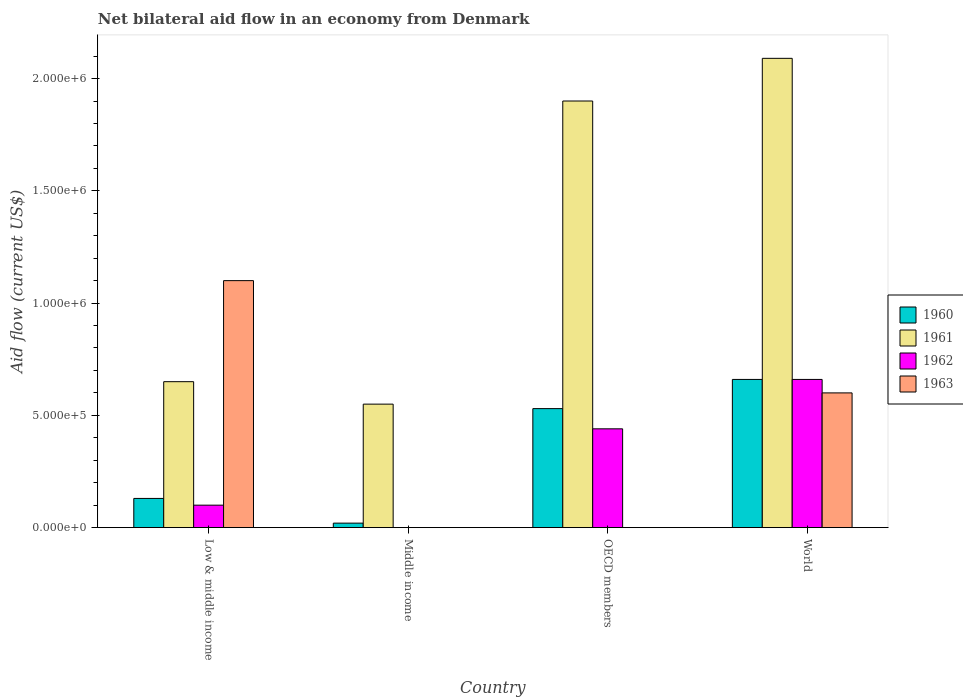How many groups of bars are there?
Keep it short and to the point. 4. Are the number of bars per tick equal to the number of legend labels?
Provide a succinct answer. No. Are the number of bars on each tick of the X-axis equal?
Give a very brief answer. No. How many bars are there on the 1st tick from the right?
Give a very brief answer. 4. What is the net bilateral aid flow in 1961 in World?
Ensure brevity in your answer.  2.09e+06. Across all countries, what is the maximum net bilateral aid flow in 1960?
Your response must be concise. 6.60e+05. Across all countries, what is the minimum net bilateral aid flow in 1962?
Offer a terse response. 0. In which country was the net bilateral aid flow in 1961 maximum?
Keep it short and to the point. World. What is the total net bilateral aid flow in 1961 in the graph?
Your response must be concise. 5.19e+06. What is the difference between the net bilateral aid flow in 1961 in World and the net bilateral aid flow in 1963 in Middle income?
Offer a very short reply. 2.09e+06. What is the average net bilateral aid flow in 1960 per country?
Your answer should be very brief. 3.35e+05. What is the difference between the net bilateral aid flow of/in 1960 and net bilateral aid flow of/in 1963 in World?
Offer a very short reply. 6.00e+04. In how many countries, is the net bilateral aid flow in 1962 greater than 500000 US$?
Keep it short and to the point. 1. What is the ratio of the net bilateral aid flow in 1963 in Low & middle income to that in World?
Your answer should be very brief. 1.83. What is the difference between the highest and the lowest net bilateral aid flow in 1960?
Keep it short and to the point. 6.40e+05. Is the sum of the net bilateral aid flow in 1961 in Middle income and OECD members greater than the maximum net bilateral aid flow in 1963 across all countries?
Your answer should be compact. Yes. Is it the case that in every country, the sum of the net bilateral aid flow in 1963 and net bilateral aid flow in 1960 is greater than the net bilateral aid flow in 1962?
Offer a very short reply. Yes. How many bars are there?
Your response must be concise. 13. Are all the bars in the graph horizontal?
Your answer should be very brief. No. How many countries are there in the graph?
Offer a very short reply. 4. Does the graph contain grids?
Make the answer very short. No. Where does the legend appear in the graph?
Provide a short and direct response. Center right. What is the title of the graph?
Offer a terse response. Net bilateral aid flow in an economy from Denmark. What is the label or title of the X-axis?
Give a very brief answer. Country. What is the label or title of the Y-axis?
Offer a terse response. Aid flow (current US$). What is the Aid flow (current US$) of 1960 in Low & middle income?
Offer a very short reply. 1.30e+05. What is the Aid flow (current US$) in 1961 in Low & middle income?
Offer a very short reply. 6.50e+05. What is the Aid flow (current US$) of 1963 in Low & middle income?
Offer a very short reply. 1.10e+06. What is the Aid flow (current US$) of 1960 in Middle income?
Offer a terse response. 2.00e+04. What is the Aid flow (current US$) of 1961 in Middle income?
Provide a succinct answer. 5.50e+05. What is the Aid flow (current US$) of 1962 in Middle income?
Ensure brevity in your answer.  0. What is the Aid flow (current US$) in 1963 in Middle income?
Give a very brief answer. 0. What is the Aid flow (current US$) in 1960 in OECD members?
Give a very brief answer. 5.30e+05. What is the Aid flow (current US$) of 1961 in OECD members?
Your answer should be very brief. 1.90e+06. What is the Aid flow (current US$) in 1962 in OECD members?
Offer a terse response. 4.40e+05. What is the Aid flow (current US$) in 1960 in World?
Your response must be concise. 6.60e+05. What is the Aid flow (current US$) of 1961 in World?
Your answer should be compact. 2.09e+06. Across all countries, what is the maximum Aid flow (current US$) in 1960?
Provide a short and direct response. 6.60e+05. Across all countries, what is the maximum Aid flow (current US$) of 1961?
Provide a short and direct response. 2.09e+06. Across all countries, what is the maximum Aid flow (current US$) in 1962?
Offer a very short reply. 6.60e+05. Across all countries, what is the maximum Aid flow (current US$) of 1963?
Keep it short and to the point. 1.10e+06. Across all countries, what is the minimum Aid flow (current US$) of 1960?
Ensure brevity in your answer.  2.00e+04. What is the total Aid flow (current US$) of 1960 in the graph?
Your response must be concise. 1.34e+06. What is the total Aid flow (current US$) of 1961 in the graph?
Make the answer very short. 5.19e+06. What is the total Aid flow (current US$) in 1962 in the graph?
Give a very brief answer. 1.20e+06. What is the total Aid flow (current US$) of 1963 in the graph?
Give a very brief answer. 1.70e+06. What is the difference between the Aid flow (current US$) in 1960 in Low & middle income and that in Middle income?
Your answer should be very brief. 1.10e+05. What is the difference between the Aid flow (current US$) of 1960 in Low & middle income and that in OECD members?
Provide a short and direct response. -4.00e+05. What is the difference between the Aid flow (current US$) in 1961 in Low & middle income and that in OECD members?
Give a very brief answer. -1.25e+06. What is the difference between the Aid flow (current US$) in 1960 in Low & middle income and that in World?
Your answer should be compact. -5.30e+05. What is the difference between the Aid flow (current US$) of 1961 in Low & middle income and that in World?
Your answer should be compact. -1.44e+06. What is the difference between the Aid flow (current US$) of 1962 in Low & middle income and that in World?
Your answer should be very brief. -5.60e+05. What is the difference between the Aid flow (current US$) of 1963 in Low & middle income and that in World?
Ensure brevity in your answer.  5.00e+05. What is the difference between the Aid flow (current US$) in 1960 in Middle income and that in OECD members?
Your answer should be compact. -5.10e+05. What is the difference between the Aid flow (current US$) of 1961 in Middle income and that in OECD members?
Your answer should be very brief. -1.35e+06. What is the difference between the Aid flow (current US$) in 1960 in Middle income and that in World?
Your response must be concise. -6.40e+05. What is the difference between the Aid flow (current US$) in 1961 in Middle income and that in World?
Keep it short and to the point. -1.54e+06. What is the difference between the Aid flow (current US$) of 1961 in OECD members and that in World?
Your answer should be very brief. -1.90e+05. What is the difference between the Aid flow (current US$) in 1962 in OECD members and that in World?
Provide a short and direct response. -2.20e+05. What is the difference between the Aid flow (current US$) in 1960 in Low & middle income and the Aid flow (current US$) in 1961 in Middle income?
Offer a very short reply. -4.20e+05. What is the difference between the Aid flow (current US$) of 1960 in Low & middle income and the Aid flow (current US$) of 1961 in OECD members?
Provide a short and direct response. -1.77e+06. What is the difference between the Aid flow (current US$) of 1960 in Low & middle income and the Aid flow (current US$) of 1962 in OECD members?
Your response must be concise. -3.10e+05. What is the difference between the Aid flow (current US$) of 1960 in Low & middle income and the Aid flow (current US$) of 1961 in World?
Make the answer very short. -1.96e+06. What is the difference between the Aid flow (current US$) in 1960 in Low & middle income and the Aid flow (current US$) in 1962 in World?
Your answer should be very brief. -5.30e+05. What is the difference between the Aid flow (current US$) in 1960 in Low & middle income and the Aid flow (current US$) in 1963 in World?
Keep it short and to the point. -4.70e+05. What is the difference between the Aid flow (current US$) in 1962 in Low & middle income and the Aid flow (current US$) in 1963 in World?
Offer a very short reply. -5.00e+05. What is the difference between the Aid flow (current US$) in 1960 in Middle income and the Aid flow (current US$) in 1961 in OECD members?
Your answer should be very brief. -1.88e+06. What is the difference between the Aid flow (current US$) in 1960 in Middle income and the Aid flow (current US$) in 1962 in OECD members?
Offer a terse response. -4.20e+05. What is the difference between the Aid flow (current US$) in 1961 in Middle income and the Aid flow (current US$) in 1962 in OECD members?
Offer a very short reply. 1.10e+05. What is the difference between the Aid flow (current US$) of 1960 in Middle income and the Aid flow (current US$) of 1961 in World?
Provide a succinct answer. -2.07e+06. What is the difference between the Aid flow (current US$) of 1960 in Middle income and the Aid flow (current US$) of 1962 in World?
Provide a succinct answer. -6.40e+05. What is the difference between the Aid flow (current US$) in 1960 in Middle income and the Aid flow (current US$) in 1963 in World?
Your response must be concise. -5.80e+05. What is the difference between the Aid flow (current US$) of 1961 in Middle income and the Aid flow (current US$) of 1962 in World?
Your answer should be very brief. -1.10e+05. What is the difference between the Aid flow (current US$) in 1960 in OECD members and the Aid flow (current US$) in 1961 in World?
Provide a short and direct response. -1.56e+06. What is the difference between the Aid flow (current US$) of 1961 in OECD members and the Aid flow (current US$) of 1962 in World?
Your response must be concise. 1.24e+06. What is the difference between the Aid flow (current US$) in 1961 in OECD members and the Aid flow (current US$) in 1963 in World?
Provide a succinct answer. 1.30e+06. What is the difference between the Aid flow (current US$) of 1962 in OECD members and the Aid flow (current US$) of 1963 in World?
Provide a succinct answer. -1.60e+05. What is the average Aid flow (current US$) in 1960 per country?
Provide a short and direct response. 3.35e+05. What is the average Aid flow (current US$) in 1961 per country?
Provide a succinct answer. 1.30e+06. What is the average Aid flow (current US$) of 1963 per country?
Offer a terse response. 4.25e+05. What is the difference between the Aid flow (current US$) in 1960 and Aid flow (current US$) in 1961 in Low & middle income?
Provide a succinct answer. -5.20e+05. What is the difference between the Aid flow (current US$) of 1960 and Aid flow (current US$) of 1963 in Low & middle income?
Give a very brief answer. -9.70e+05. What is the difference between the Aid flow (current US$) in 1961 and Aid flow (current US$) in 1962 in Low & middle income?
Give a very brief answer. 5.50e+05. What is the difference between the Aid flow (current US$) of 1961 and Aid flow (current US$) of 1963 in Low & middle income?
Your answer should be very brief. -4.50e+05. What is the difference between the Aid flow (current US$) of 1960 and Aid flow (current US$) of 1961 in Middle income?
Keep it short and to the point. -5.30e+05. What is the difference between the Aid flow (current US$) in 1960 and Aid flow (current US$) in 1961 in OECD members?
Offer a terse response. -1.37e+06. What is the difference between the Aid flow (current US$) of 1961 and Aid flow (current US$) of 1962 in OECD members?
Offer a terse response. 1.46e+06. What is the difference between the Aid flow (current US$) of 1960 and Aid flow (current US$) of 1961 in World?
Offer a very short reply. -1.43e+06. What is the difference between the Aid flow (current US$) in 1961 and Aid flow (current US$) in 1962 in World?
Your response must be concise. 1.43e+06. What is the difference between the Aid flow (current US$) of 1961 and Aid flow (current US$) of 1963 in World?
Your response must be concise. 1.49e+06. What is the ratio of the Aid flow (current US$) in 1960 in Low & middle income to that in Middle income?
Your response must be concise. 6.5. What is the ratio of the Aid flow (current US$) of 1961 in Low & middle income to that in Middle income?
Make the answer very short. 1.18. What is the ratio of the Aid flow (current US$) of 1960 in Low & middle income to that in OECD members?
Ensure brevity in your answer.  0.25. What is the ratio of the Aid flow (current US$) of 1961 in Low & middle income to that in OECD members?
Keep it short and to the point. 0.34. What is the ratio of the Aid flow (current US$) in 1962 in Low & middle income to that in OECD members?
Provide a succinct answer. 0.23. What is the ratio of the Aid flow (current US$) of 1960 in Low & middle income to that in World?
Make the answer very short. 0.2. What is the ratio of the Aid flow (current US$) in 1961 in Low & middle income to that in World?
Your answer should be compact. 0.31. What is the ratio of the Aid flow (current US$) of 1962 in Low & middle income to that in World?
Offer a very short reply. 0.15. What is the ratio of the Aid flow (current US$) in 1963 in Low & middle income to that in World?
Offer a very short reply. 1.83. What is the ratio of the Aid flow (current US$) in 1960 in Middle income to that in OECD members?
Your answer should be compact. 0.04. What is the ratio of the Aid flow (current US$) in 1961 in Middle income to that in OECD members?
Ensure brevity in your answer.  0.29. What is the ratio of the Aid flow (current US$) in 1960 in Middle income to that in World?
Offer a terse response. 0.03. What is the ratio of the Aid flow (current US$) in 1961 in Middle income to that in World?
Offer a very short reply. 0.26. What is the ratio of the Aid flow (current US$) in 1960 in OECD members to that in World?
Your answer should be compact. 0.8. What is the ratio of the Aid flow (current US$) of 1961 in OECD members to that in World?
Your answer should be compact. 0.91. What is the difference between the highest and the second highest Aid flow (current US$) in 1960?
Your answer should be compact. 1.30e+05. What is the difference between the highest and the second highest Aid flow (current US$) in 1961?
Your answer should be very brief. 1.90e+05. What is the difference between the highest and the lowest Aid flow (current US$) in 1960?
Keep it short and to the point. 6.40e+05. What is the difference between the highest and the lowest Aid flow (current US$) in 1961?
Your answer should be very brief. 1.54e+06. What is the difference between the highest and the lowest Aid flow (current US$) of 1962?
Offer a very short reply. 6.60e+05. What is the difference between the highest and the lowest Aid flow (current US$) in 1963?
Offer a very short reply. 1.10e+06. 